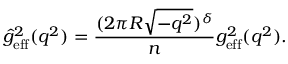<formula> <loc_0><loc_0><loc_500><loc_500>\hat { g } _ { e f f } ^ { 2 } ( q ^ { 2 } ) = \frac { ( 2 \pi R \sqrt { - q ^ { 2 } } ) ^ { \delta } } { n } g _ { e f f } ^ { 2 } ( q ^ { 2 } ) .</formula> 